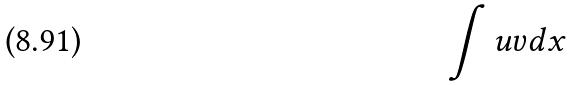Convert formula to latex. <formula><loc_0><loc_0><loc_500><loc_500>\int u v d x</formula> 